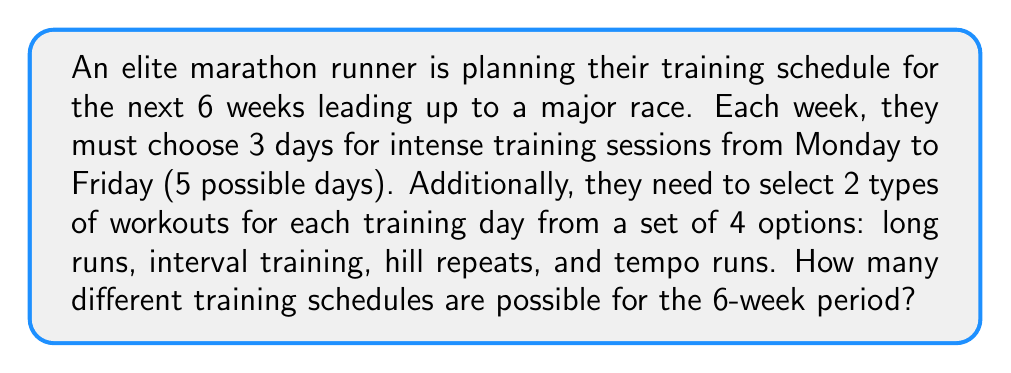Could you help me with this problem? Let's break this down step-by-step:

1) First, let's consider the choices for a single week:

   a) Choosing 3 days out of 5:
      This can be done in $\binom{5}{3}$ ways.
      $$\binom{5}{3} = \frac{5!}{3!(5-3)!} = \frac{5 \cdot 4 \cdot 3}{3 \cdot 2 \cdot 1} = 10$$

   b) For each of these 3 days, we need to choose 2 types of workouts out of 4:
      This can be done in $\binom{4}{2}$ ways.
      $$\binom{4}{2} = \frac{4!}{2!(4-2)!} = \frac{4 \cdot 3}{2 \cdot 1} = 6$$

   c) The choices for each day are independent, so we multiply:
      $6 \cdot 6 \cdot 6 = 216$

   d) The total number of possibilities for one week is thus:
      $10 \cdot 216 = 2,160$

2) Now, we need to consider this for 6 weeks:

   The choices for each week are independent, so we raise our result to the power of 6:

   $2,160^6$

3) Calculate the final result:
   $$2,160^6 = 85,766,121,236,767,743,999,999,999,000,000$$
Answer: $85,766,121,236,767,743,999,999,999,000,000$ 